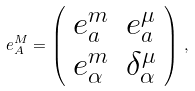Convert formula to latex. <formula><loc_0><loc_0><loc_500><loc_500>e ^ { M } _ { A } = \left ( \begin{array} { c c } e ^ { m } _ { a } & e ^ { \mu } _ { a } \\ e ^ { m } _ { \alpha } & \delta ^ { \mu } _ { \alpha } \end{array} \right ) \, ,</formula> 